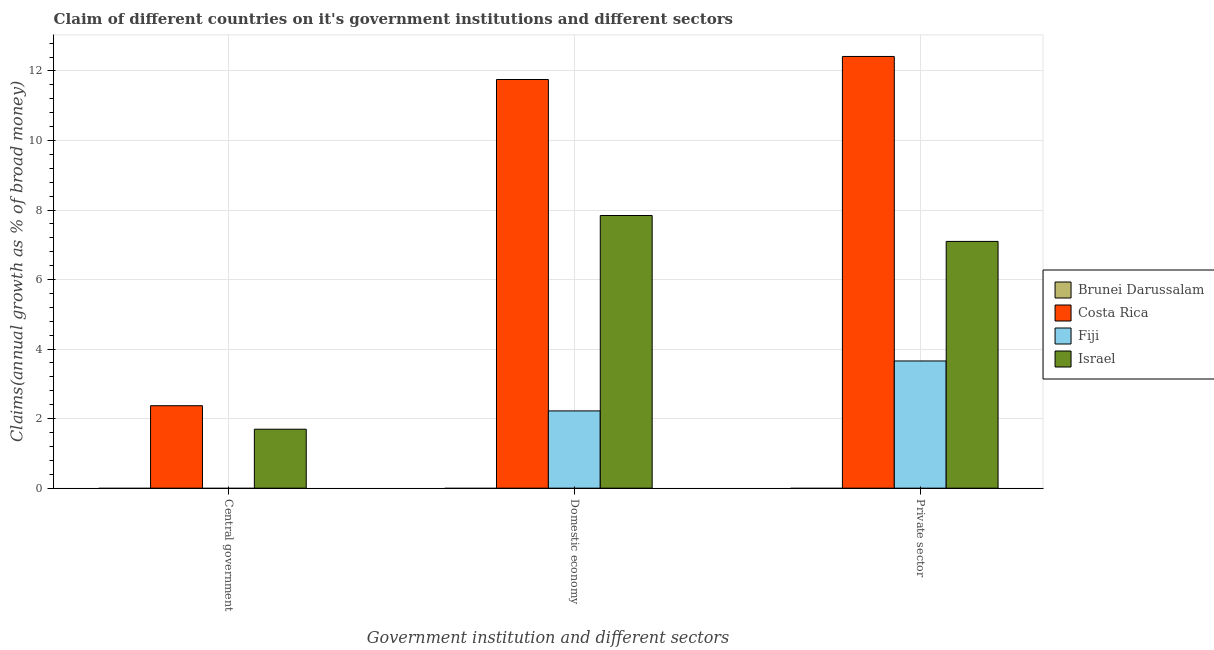How many different coloured bars are there?
Your answer should be very brief. 3. How many groups of bars are there?
Make the answer very short. 3. Are the number of bars on each tick of the X-axis equal?
Your answer should be very brief. No. How many bars are there on the 1st tick from the left?
Give a very brief answer. 2. What is the label of the 3rd group of bars from the left?
Offer a very short reply. Private sector. What is the percentage of claim on the central government in Brunei Darussalam?
Your answer should be very brief. 0. Across all countries, what is the maximum percentage of claim on the private sector?
Provide a short and direct response. 12.42. In which country was the percentage of claim on the domestic economy maximum?
Offer a very short reply. Costa Rica. What is the total percentage of claim on the central government in the graph?
Provide a short and direct response. 4.07. What is the difference between the percentage of claim on the private sector in Costa Rica and that in Israel?
Make the answer very short. 5.32. What is the difference between the percentage of claim on the private sector in Costa Rica and the percentage of claim on the domestic economy in Israel?
Your answer should be compact. 4.57. What is the average percentage of claim on the domestic economy per country?
Provide a succinct answer. 5.45. What is the difference between the percentage of claim on the private sector and percentage of claim on the domestic economy in Costa Rica?
Make the answer very short. 0.66. What is the ratio of the percentage of claim on the private sector in Costa Rica to that in Israel?
Your answer should be very brief. 1.75. Is the percentage of claim on the private sector in Israel less than that in Fiji?
Provide a succinct answer. No. Is the difference between the percentage of claim on the private sector in Costa Rica and Israel greater than the difference between the percentage of claim on the domestic economy in Costa Rica and Israel?
Ensure brevity in your answer.  Yes. What is the difference between the highest and the second highest percentage of claim on the private sector?
Provide a succinct answer. 5.32. What is the difference between the highest and the lowest percentage of claim on the private sector?
Your response must be concise. 12.42. In how many countries, is the percentage of claim on the private sector greater than the average percentage of claim on the private sector taken over all countries?
Your answer should be very brief. 2. How many bars are there?
Keep it short and to the point. 8. Are the values on the major ticks of Y-axis written in scientific E-notation?
Ensure brevity in your answer.  No. How are the legend labels stacked?
Make the answer very short. Vertical. What is the title of the graph?
Provide a succinct answer. Claim of different countries on it's government institutions and different sectors. Does "Hong Kong" appear as one of the legend labels in the graph?
Provide a succinct answer. No. What is the label or title of the X-axis?
Make the answer very short. Government institution and different sectors. What is the label or title of the Y-axis?
Provide a short and direct response. Claims(annual growth as % of broad money). What is the Claims(annual growth as % of broad money) in Costa Rica in Central government?
Provide a succinct answer. 2.37. What is the Claims(annual growth as % of broad money) in Fiji in Central government?
Offer a very short reply. 0. What is the Claims(annual growth as % of broad money) in Israel in Central government?
Ensure brevity in your answer.  1.7. What is the Claims(annual growth as % of broad money) in Brunei Darussalam in Domestic economy?
Provide a short and direct response. 0. What is the Claims(annual growth as % of broad money) in Costa Rica in Domestic economy?
Your answer should be compact. 11.75. What is the Claims(annual growth as % of broad money) of Fiji in Domestic economy?
Your answer should be compact. 2.22. What is the Claims(annual growth as % of broad money) of Israel in Domestic economy?
Offer a very short reply. 7.84. What is the Claims(annual growth as % of broad money) of Costa Rica in Private sector?
Your answer should be compact. 12.42. What is the Claims(annual growth as % of broad money) in Fiji in Private sector?
Offer a terse response. 3.66. What is the Claims(annual growth as % of broad money) in Israel in Private sector?
Offer a terse response. 7.1. Across all Government institution and different sectors, what is the maximum Claims(annual growth as % of broad money) in Costa Rica?
Provide a short and direct response. 12.42. Across all Government institution and different sectors, what is the maximum Claims(annual growth as % of broad money) in Fiji?
Offer a terse response. 3.66. Across all Government institution and different sectors, what is the maximum Claims(annual growth as % of broad money) of Israel?
Provide a succinct answer. 7.84. Across all Government institution and different sectors, what is the minimum Claims(annual growth as % of broad money) of Costa Rica?
Your response must be concise. 2.37. Across all Government institution and different sectors, what is the minimum Claims(annual growth as % of broad money) in Fiji?
Provide a succinct answer. 0. Across all Government institution and different sectors, what is the minimum Claims(annual growth as % of broad money) of Israel?
Offer a terse response. 1.7. What is the total Claims(annual growth as % of broad money) in Brunei Darussalam in the graph?
Provide a succinct answer. 0. What is the total Claims(annual growth as % of broad money) of Costa Rica in the graph?
Your answer should be very brief. 26.54. What is the total Claims(annual growth as % of broad money) of Fiji in the graph?
Provide a succinct answer. 5.88. What is the total Claims(annual growth as % of broad money) in Israel in the graph?
Provide a short and direct response. 16.63. What is the difference between the Claims(annual growth as % of broad money) in Costa Rica in Central government and that in Domestic economy?
Offer a terse response. -9.38. What is the difference between the Claims(annual growth as % of broad money) of Israel in Central government and that in Domestic economy?
Your answer should be compact. -6.15. What is the difference between the Claims(annual growth as % of broad money) of Costa Rica in Central government and that in Private sector?
Keep it short and to the point. -10.05. What is the difference between the Claims(annual growth as % of broad money) of Israel in Central government and that in Private sector?
Your answer should be compact. -5.4. What is the difference between the Claims(annual growth as % of broad money) of Costa Rica in Domestic economy and that in Private sector?
Keep it short and to the point. -0.66. What is the difference between the Claims(annual growth as % of broad money) in Fiji in Domestic economy and that in Private sector?
Ensure brevity in your answer.  -1.44. What is the difference between the Claims(annual growth as % of broad money) of Israel in Domestic economy and that in Private sector?
Your response must be concise. 0.74. What is the difference between the Claims(annual growth as % of broad money) of Costa Rica in Central government and the Claims(annual growth as % of broad money) of Fiji in Domestic economy?
Give a very brief answer. 0.15. What is the difference between the Claims(annual growth as % of broad money) in Costa Rica in Central government and the Claims(annual growth as % of broad money) in Israel in Domestic economy?
Your answer should be very brief. -5.47. What is the difference between the Claims(annual growth as % of broad money) in Costa Rica in Central government and the Claims(annual growth as % of broad money) in Fiji in Private sector?
Offer a terse response. -1.29. What is the difference between the Claims(annual growth as % of broad money) in Costa Rica in Central government and the Claims(annual growth as % of broad money) in Israel in Private sector?
Your answer should be compact. -4.73. What is the difference between the Claims(annual growth as % of broad money) in Costa Rica in Domestic economy and the Claims(annual growth as % of broad money) in Fiji in Private sector?
Offer a very short reply. 8.1. What is the difference between the Claims(annual growth as % of broad money) of Costa Rica in Domestic economy and the Claims(annual growth as % of broad money) of Israel in Private sector?
Your answer should be compact. 4.66. What is the difference between the Claims(annual growth as % of broad money) in Fiji in Domestic economy and the Claims(annual growth as % of broad money) in Israel in Private sector?
Your answer should be compact. -4.88. What is the average Claims(annual growth as % of broad money) of Costa Rica per Government institution and different sectors?
Offer a terse response. 8.85. What is the average Claims(annual growth as % of broad money) of Fiji per Government institution and different sectors?
Ensure brevity in your answer.  1.96. What is the average Claims(annual growth as % of broad money) of Israel per Government institution and different sectors?
Provide a short and direct response. 5.54. What is the difference between the Claims(annual growth as % of broad money) of Costa Rica and Claims(annual growth as % of broad money) of Israel in Central government?
Give a very brief answer. 0.68. What is the difference between the Claims(annual growth as % of broad money) of Costa Rica and Claims(annual growth as % of broad money) of Fiji in Domestic economy?
Your answer should be very brief. 9.53. What is the difference between the Claims(annual growth as % of broad money) in Costa Rica and Claims(annual growth as % of broad money) in Israel in Domestic economy?
Your answer should be very brief. 3.91. What is the difference between the Claims(annual growth as % of broad money) of Fiji and Claims(annual growth as % of broad money) of Israel in Domestic economy?
Ensure brevity in your answer.  -5.62. What is the difference between the Claims(annual growth as % of broad money) of Costa Rica and Claims(annual growth as % of broad money) of Fiji in Private sector?
Provide a short and direct response. 8.76. What is the difference between the Claims(annual growth as % of broad money) in Costa Rica and Claims(annual growth as % of broad money) in Israel in Private sector?
Your answer should be very brief. 5.32. What is the difference between the Claims(annual growth as % of broad money) in Fiji and Claims(annual growth as % of broad money) in Israel in Private sector?
Provide a short and direct response. -3.44. What is the ratio of the Claims(annual growth as % of broad money) in Costa Rica in Central government to that in Domestic economy?
Make the answer very short. 0.2. What is the ratio of the Claims(annual growth as % of broad money) of Israel in Central government to that in Domestic economy?
Provide a succinct answer. 0.22. What is the ratio of the Claims(annual growth as % of broad money) in Costa Rica in Central government to that in Private sector?
Keep it short and to the point. 0.19. What is the ratio of the Claims(annual growth as % of broad money) in Israel in Central government to that in Private sector?
Make the answer very short. 0.24. What is the ratio of the Claims(annual growth as % of broad money) of Costa Rica in Domestic economy to that in Private sector?
Your response must be concise. 0.95. What is the ratio of the Claims(annual growth as % of broad money) in Fiji in Domestic economy to that in Private sector?
Your answer should be compact. 0.61. What is the ratio of the Claims(annual growth as % of broad money) of Israel in Domestic economy to that in Private sector?
Ensure brevity in your answer.  1.1. What is the difference between the highest and the second highest Claims(annual growth as % of broad money) of Costa Rica?
Give a very brief answer. 0.66. What is the difference between the highest and the second highest Claims(annual growth as % of broad money) of Israel?
Offer a terse response. 0.74. What is the difference between the highest and the lowest Claims(annual growth as % of broad money) of Costa Rica?
Your answer should be very brief. 10.05. What is the difference between the highest and the lowest Claims(annual growth as % of broad money) in Fiji?
Your response must be concise. 3.66. What is the difference between the highest and the lowest Claims(annual growth as % of broad money) of Israel?
Give a very brief answer. 6.15. 